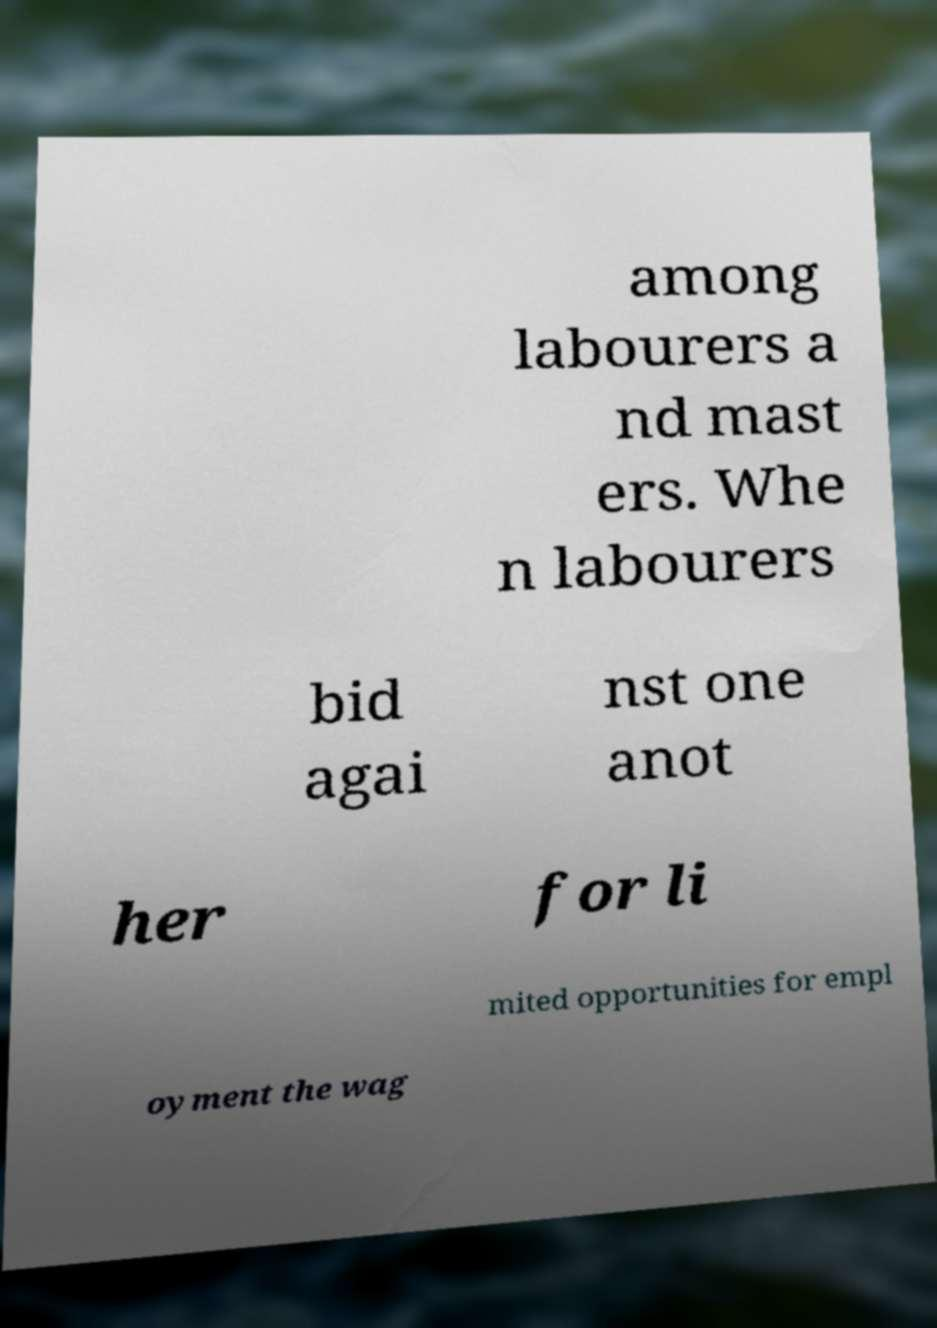There's text embedded in this image that I need extracted. Can you transcribe it verbatim? among labourers a nd mast ers. Whe n labourers bid agai nst one anot her for li mited opportunities for empl oyment the wag 